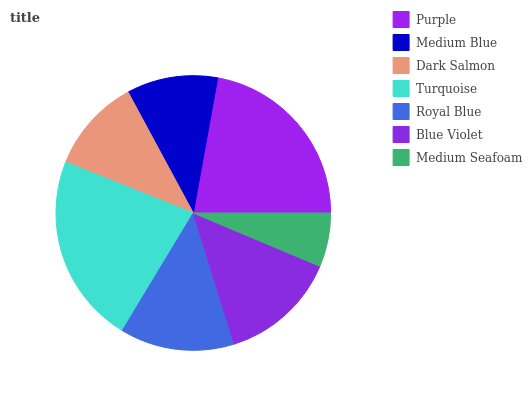Is Medium Seafoam the minimum?
Answer yes or no. Yes. Is Turquoise the maximum?
Answer yes or no. Yes. Is Medium Blue the minimum?
Answer yes or no. No. Is Medium Blue the maximum?
Answer yes or no. No. Is Purple greater than Medium Blue?
Answer yes or no. Yes. Is Medium Blue less than Purple?
Answer yes or no. Yes. Is Medium Blue greater than Purple?
Answer yes or no. No. Is Purple less than Medium Blue?
Answer yes or no. No. Is Royal Blue the high median?
Answer yes or no. Yes. Is Royal Blue the low median?
Answer yes or no. Yes. Is Medium Blue the high median?
Answer yes or no. No. Is Purple the low median?
Answer yes or no. No. 